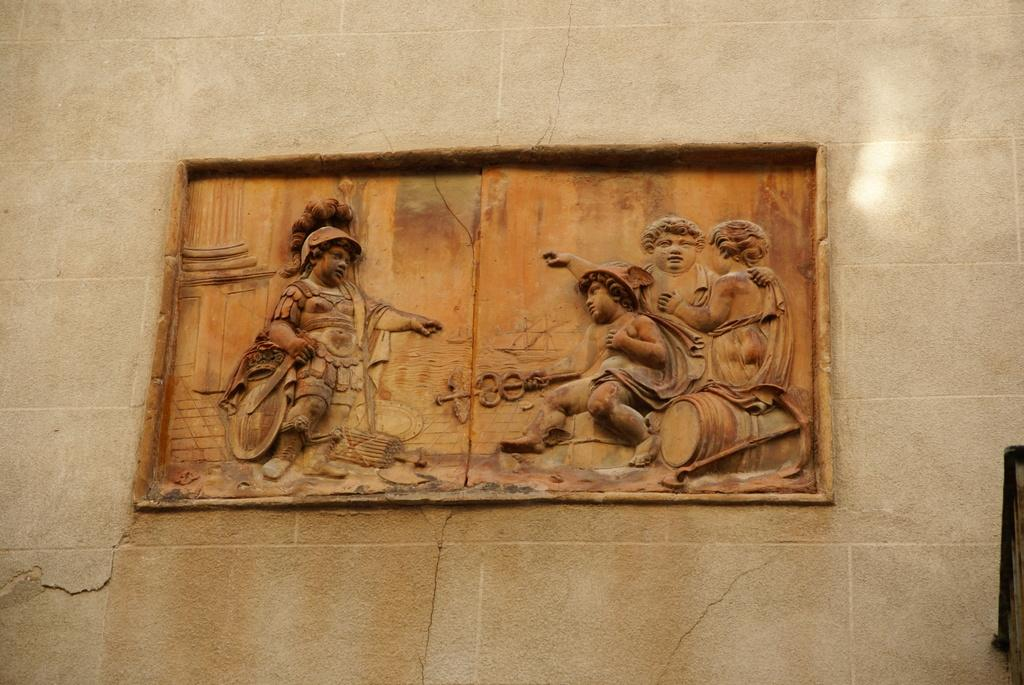What can be seen carved on the wall in the image? There are sculptures carved on the wall in the image. What is the sculpture's opinion on the ongoing competition in the image? The sculpture is a carved object and does not have an opinion, as it is not a living being capable of forming opinions. 